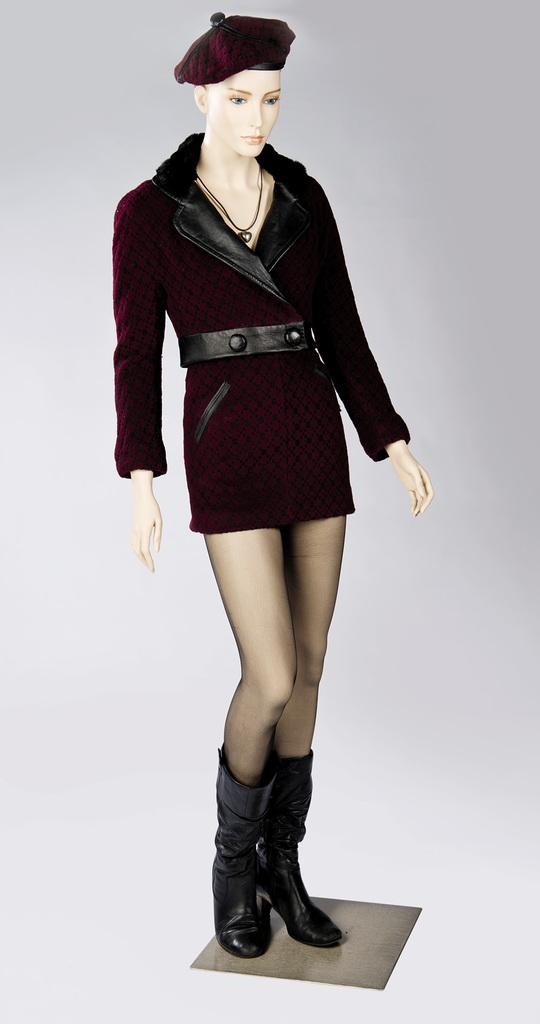What is the main subject of the image? There is a woman mannequin in the image. What is the mannequin wearing? The mannequin is wearing a brown dress, a cap, and black shoes. What type of industry can be seen in the background of the image? There is no industry visible in the image; it only features the woman mannequin and her clothing. How many ears of corn are on the shelf behind the mannequin? There is no shelf or corn present in the image. 